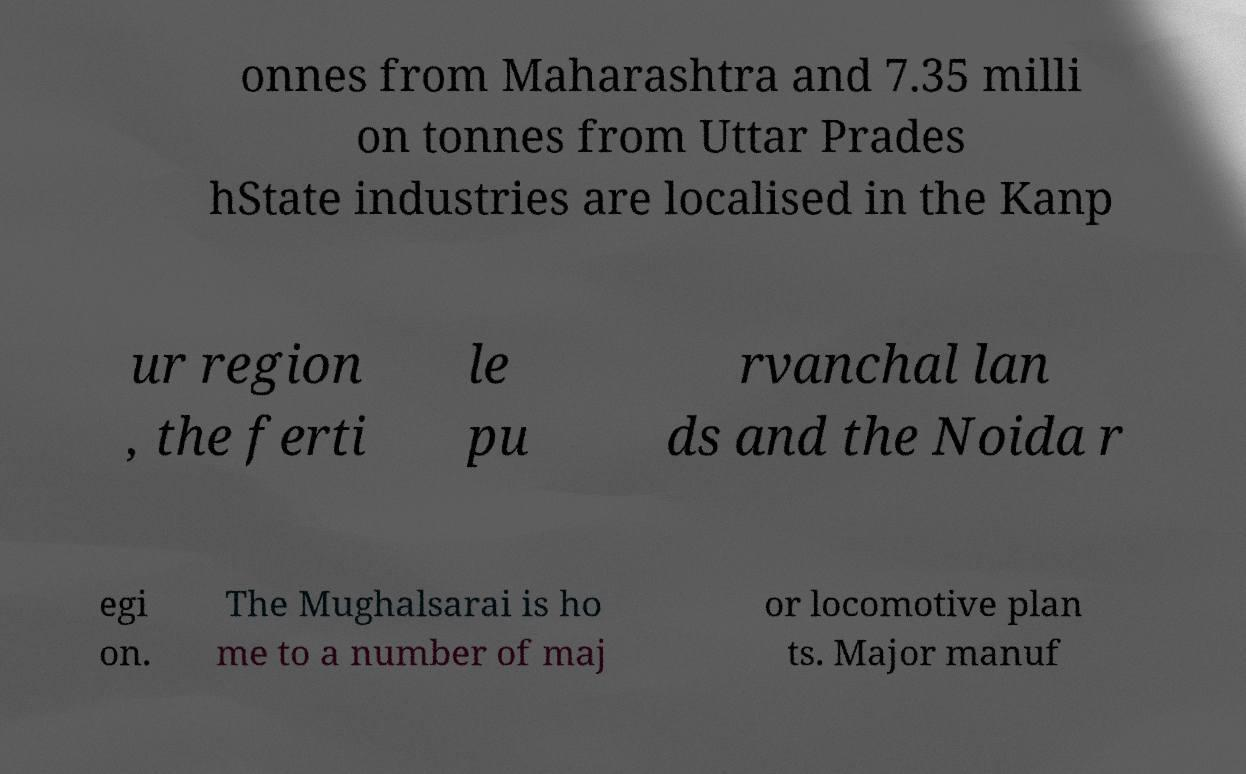There's text embedded in this image that I need extracted. Can you transcribe it verbatim? onnes from Maharashtra and 7.35 milli on tonnes from Uttar Prades hState industries are localised in the Kanp ur region , the ferti le pu rvanchal lan ds and the Noida r egi on. The Mughalsarai is ho me to a number of maj or locomotive plan ts. Major manuf 